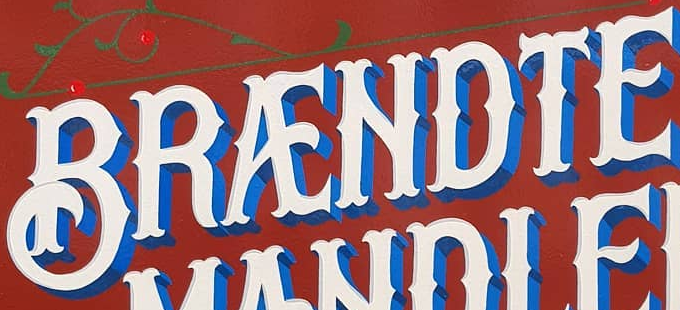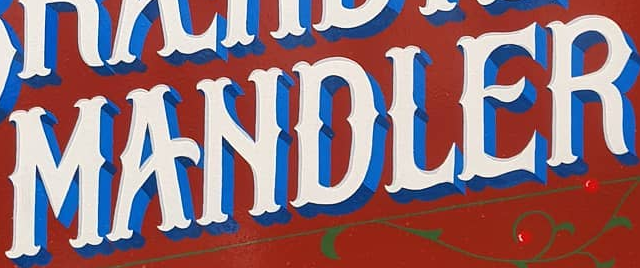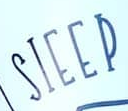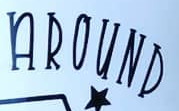Read the text content from these images in order, separated by a semicolon. BRÆNDTE; MANDLER; SIEEP; AROUND 